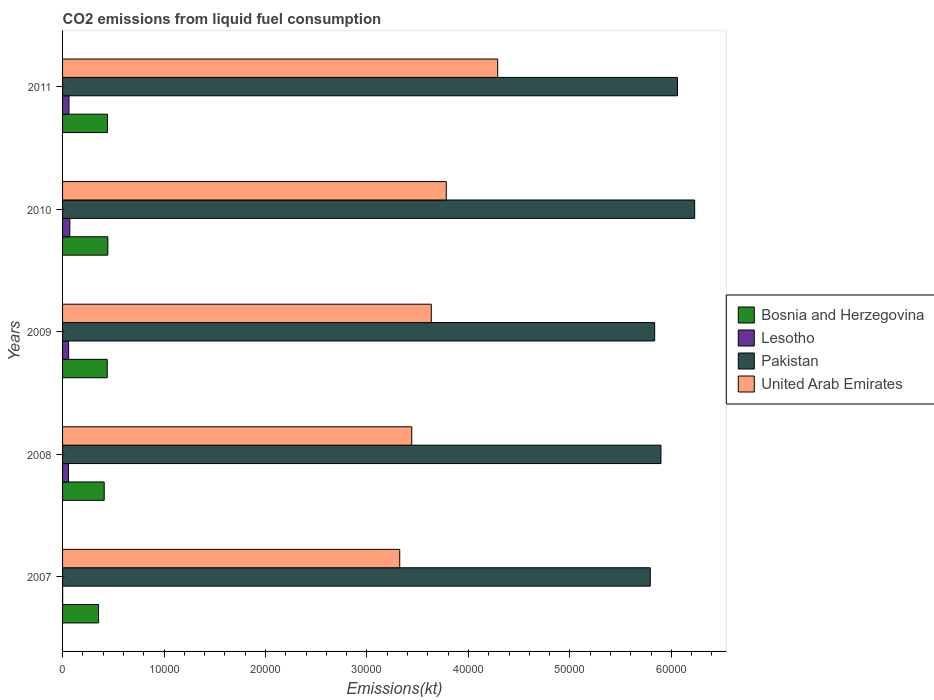How many different coloured bars are there?
Offer a very short reply. 4. How many groups of bars are there?
Ensure brevity in your answer.  5. Are the number of bars per tick equal to the number of legend labels?
Give a very brief answer. Yes. Are the number of bars on each tick of the Y-axis equal?
Keep it short and to the point. Yes. In how many cases, is the number of bars for a given year not equal to the number of legend labels?
Your response must be concise. 0. What is the amount of CO2 emitted in Bosnia and Herzegovina in 2008?
Ensure brevity in your answer.  4103.37. Across all years, what is the maximum amount of CO2 emitted in Lesotho?
Your response must be concise. 715.07. Across all years, what is the minimum amount of CO2 emitted in Bosnia and Herzegovina?
Give a very brief answer. 3545.99. What is the total amount of CO2 emitted in Lesotho in the graph?
Offer a very short reply. 2533.9. What is the difference between the amount of CO2 emitted in Lesotho in 2007 and that in 2009?
Your response must be concise. -586.72. What is the difference between the amount of CO2 emitted in Bosnia and Herzegovina in 2010 and the amount of CO2 emitted in Pakistan in 2011?
Ensure brevity in your answer.  -5.61e+04. What is the average amount of CO2 emitted in Pakistan per year?
Keep it short and to the point. 5.96e+04. In the year 2009, what is the difference between the amount of CO2 emitted in Pakistan and amount of CO2 emitted in Bosnia and Herzegovina?
Offer a very short reply. 5.40e+04. In how many years, is the amount of CO2 emitted in Lesotho greater than 2000 kt?
Ensure brevity in your answer.  0. What is the ratio of the amount of CO2 emitted in Bosnia and Herzegovina in 2007 to that in 2009?
Your answer should be very brief. 0.81. Is the difference between the amount of CO2 emitted in Pakistan in 2007 and 2010 greater than the difference between the amount of CO2 emitted in Bosnia and Herzegovina in 2007 and 2010?
Provide a short and direct response. No. What is the difference between the highest and the second highest amount of CO2 emitted in United Arab Emirates?
Keep it short and to the point. 5067.79. What is the difference between the highest and the lowest amount of CO2 emitted in United Arab Emirates?
Provide a short and direct response. 9655.21. In how many years, is the amount of CO2 emitted in United Arab Emirates greater than the average amount of CO2 emitted in United Arab Emirates taken over all years?
Keep it short and to the point. 2. Is the sum of the amount of CO2 emitted in Pakistan in 2009 and 2011 greater than the maximum amount of CO2 emitted in Lesotho across all years?
Your response must be concise. Yes. Is it the case that in every year, the sum of the amount of CO2 emitted in Lesotho and amount of CO2 emitted in Bosnia and Herzegovina is greater than the sum of amount of CO2 emitted in United Arab Emirates and amount of CO2 emitted in Pakistan?
Provide a succinct answer. No. What does the 1st bar from the top in 2010 represents?
Your answer should be compact. United Arab Emirates. Is it the case that in every year, the sum of the amount of CO2 emitted in Lesotho and amount of CO2 emitted in Pakistan is greater than the amount of CO2 emitted in Bosnia and Herzegovina?
Keep it short and to the point. Yes. How many years are there in the graph?
Your answer should be very brief. 5. Does the graph contain grids?
Your answer should be very brief. No. How many legend labels are there?
Offer a terse response. 4. What is the title of the graph?
Make the answer very short. CO2 emissions from liquid fuel consumption. What is the label or title of the X-axis?
Provide a short and direct response. Emissions(kt). What is the Emissions(kt) of Bosnia and Herzegovina in 2007?
Make the answer very short. 3545.99. What is the Emissions(kt) of Lesotho in 2007?
Ensure brevity in your answer.  7.33. What is the Emissions(kt) in Pakistan in 2007?
Provide a succinct answer. 5.79e+04. What is the Emissions(kt) of United Arab Emirates in 2007?
Provide a short and direct response. 3.32e+04. What is the Emissions(kt) in Bosnia and Herzegovina in 2008?
Give a very brief answer. 4103.37. What is the Emissions(kt) of Lesotho in 2008?
Make the answer very short. 586.72. What is the Emissions(kt) of Pakistan in 2008?
Give a very brief answer. 5.90e+04. What is the Emissions(kt) in United Arab Emirates in 2008?
Your response must be concise. 3.44e+04. What is the Emissions(kt) in Bosnia and Herzegovina in 2009?
Provide a short and direct response. 4400.4. What is the Emissions(kt) in Lesotho in 2009?
Make the answer very short. 594.05. What is the Emissions(kt) of Pakistan in 2009?
Make the answer very short. 5.84e+04. What is the Emissions(kt) of United Arab Emirates in 2009?
Give a very brief answer. 3.63e+04. What is the Emissions(kt) of Bosnia and Herzegovina in 2010?
Your answer should be very brief. 4462.74. What is the Emissions(kt) of Lesotho in 2010?
Offer a terse response. 715.07. What is the Emissions(kt) of Pakistan in 2010?
Give a very brief answer. 6.23e+04. What is the Emissions(kt) in United Arab Emirates in 2010?
Provide a short and direct response. 3.78e+04. What is the Emissions(kt) of Bosnia and Herzegovina in 2011?
Provide a short and direct response. 4422.4. What is the Emissions(kt) in Lesotho in 2011?
Your answer should be compact. 630.72. What is the Emissions(kt) of Pakistan in 2011?
Offer a terse response. 6.06e+04. What is the Emissions(kt) in United Arab Emirates in 2011?
Make the answer very short. 4.29e+04. Across all years, what is the maximum Emissions(kt) of Bosnia and Herzegovina?
Offer a terse response. 4462.74. Across all years, what is the maximum Emissions(kt) in Lesotho?
Your response must be concise. 715.07. Across all years, what is the maximum Emissions(kt) in Pakistan?
Keep it short and to the point. 6.23e+04. Across all years, what is the maximum Emissions(kt) in United Arab Emirates?
Provide a short and direct response. 4.29e+04. Across all years, what is the minimum Emissions(kt) in Bosnia and Herzegovina?
Make the answer very short. 3545.99. Across all years, what is the minimum Emissions(kt) of Lesotho?
Keep it short and to the point. 7.33. Across all years, what is the minimum Emissions(kt) of Pakistan?
Offer a terse response. 5.79e+04. Across all years, what is the minimum Emissions(kt) in United Arab Emirates?
Your response must be concise. 3.32e+04. What is the total Emissions(kt) of Bosnia and Herzegovina in the graph?
Your response must be concise. 2.09e+04. What is the total Emissions(kt) in Lesotho in the graph?
Offer a terse response. 2533.9. What is the total Emissions(kt) in Pakistan in the graph?
Ensure brevity in your answer.  2.98e+05. What is the total Emissions(kt) in United Arab Emirates in the graph?
Offer a very short reply. 1.85e+05. What is the difference between the Emissions(kt) in Bosnia and Herzegovina in 2007 and that in 2008?
Your answer should be very brief. -557.38. What is the difference between the Emissions(kt) in Lesotho in 2007 and that in 2008?
Provide a short and direct response. -579.39. What is the difference between the Emissions(kt) of Pakistan in 2007 and that in 2008?
Ensure brevity in your answer.  -1052.43. What is the difference between the Emissions(kt) in United Arab Emirates in 2007 and that in 2008?
Provide a succinct answer. -1184.44. What is the difference between the Emissions(kt) in Bosnia and Herzegovina in 2007 and that in 2009?
Ensure brevity in your answer.  -854.41. What is the difference between the Emissions(kt) in Lesotho in 2007 and that in 2009?
Keep it short and to the point. -586.72. What is the difference between the Emissions(kt) in Pakistan in 2007 and that in 2009?
Keep it short and to the point. -432.71. What is the difference between the Emissions(kt) of United Arab Emirates in 2007 and that in 2009?
Offer a very short reply. -3109.62. What is the difference between the Emissions(kt) in Bosnia and Herzegovina in 2007 and that in 2010?
Ensure brevity in your answer.  -916.75. What is the difference between the Emissions(kt) of Lesotho in 2007 and that in 2010?
Your answer should be very brief. -707.73. What is the difference between the Emissions(kt) in Pakistan in 2007 and that in 2010?
Your response must be concise. -4374.73. What is the difference between the Emissions(kt) of United Arab Emirates in 2007 and that in 2010?
Ensure brevity in your answer.  -4587.42. What is the difference between the Emissions(kt) in Bosnia and Herzegovina in 2007 and that in 2011?
Offer a terse response. -876.41. What is the difference between the Emissions(kt) of Lesotho in 2007 and that in 2011?
Your answer should be very brief. -623.39. What is the difference between the Emissions(kt) of Pakistan in 2007 and that in 2011?
Make the answer very short. -2684.24. What is the difference between the Emissions(kt) of United Arab Emirates in 2007 and that in 2011?
Your response must be concise. -9655.21. What is the difference between the Emissions(kt) in Bosnia and Herzegovina in 2008 and that in 2009?
Make the answer very short. -297.03. What is the difference between the Emissions(kt) in Lesotho in 2008 and that in 2009?
Your response must be concise. -7.33. What is the difference between the Emissions(kt) of Pakistan in 2008 and that in 2009?
Your response must be concise. 619.72. What is the difference between the Emissions(kt) in United Arab Emirates in 2008 and that in 2009?
Your answer should be very brief. -1925.17. What is the difference between the Emissions(kt) of Bosnia and Herzegovina in 2008 and that in 2010?
Your answer should be very brief. -359.37. What is the difference between the Emissions(kt) of Lesotho in 2008 and that in 2010?
Ensure brevity in your answer.  -128.34. What is the difference between the Emissions(kt) in Pakistan in 2008 and that in 2010?
Provide a short and direct response. -3322.3. What is the difference between the Emissions(kt) in United Arab Emirates in 2008 and that in 2010?
Give a very brief answer. -3402.98. What is the difference between the Emissions(kt) in Bosnia and Herzegovina in 2008 and that in 2011?
Offer a terse response. -319.03. What is the difference between the Emissions(kt) of Lesotho in 2008 and that in 2011?
Keep it short and to the point. -44. What is the difference between the Emissions(kt) of Pakistan in 2008 and that in 2011?
Provide a short and direct response. -1631.82. What is the difference between the Emissions(kt) in United Arab Emirates in 2008 and that in 2011?
Your response must be concise. -8470.77. What is the difference between the Emissions(kt) in Bosnia and Herzegovina in 2009 and that in 2010?
Offer a terse response. -62.34. What is the difference between the Emissions(kt) of Lesotho in 2009 and that in 2010?
Ensure brevity in your answer.  -121.01. What is the difference between the Emissions(kt) of Pakistan in 2009 and that in 2010?
Your response must be concise. -3942.03. What is the difference between the Emissions(kt) in United Arab Emirates in 2009 and that in 2010?
Provide a succinct answer. -1477.8. What is the difference between the Emissions(kt) in Bosnia and Herzegovina in 2009 and that in 2011?
Your response must be concise. -22. What is the difference between the Emissions(kt) in Lesotho in 2009 and that in 2011?
Provide a short and direct response. -36.67. What is the difference between the Emissions(kt) of Pakistan in 2009 and that in 2011?
Keep it short and to the point. -2251.54. What is the difference between the Emissions(kt) in United Arab Emirates in 2009 and that in 2011?
Provide a succinct answer. -6545.6. What is the difference between the Emissions(kt) of Bosnia and Herzegovina in 2010 and that in 2011?
Your response must be concise. 40.34. What is the difference between the Emissions(kt) in Lesotho in 2010 and that in 2011?
Ensure brevity in your answer.  84.34. What is the difference between the Emissions(kt) of Pakistan in 2010 and that in 2011?
Keep it short and to the point. 1690.49. What is the difference between the Emissions(kt) in United Arab Emirates in 2010 and that in 2011?
Offer a very short reply. -5067.79. What is the difference between the Emissions(kt) of Bosnia and Herzegovina in 2007 and the Emissions(kt) of Lesotho in 2008?
Keep it short and to the point. 2959.27. What is the difference between the Emissions(kt) in Bosnia and Herzegovina in 2007 and the Emissions(kt) in Pakistan in 2008?
Offer a very short reply. -5.54e+04. What is the difference between the Emissions(kt) in Bosnia and Herzegovina in 2007 and the Emissions(kt) in United Arab Emirates in 2008?
Ensure brevity in your answer.  -3.09e+04. What is the difference between the Emissions(kt) of Lesotho in 2007 and the Emissions(kt) of Pakistan in 2008?
Provide a short and direct response. -5.90e+04. What is the difference between the Emissions(kt) of Lesotho in 2007 and the Emissions(kt) of United Arab Emirates in 2008?
Offer a terse response. -3.44e+04. What is the difference between the Emissions(kt) in Pakistan in 2007 and the Emissions(kt) in United Arab Emirates in 2008?
Offer a very short reply. 2.35e+04. What is the difference between the Emissions(kt) of Bosnia and Herzegovina in 2007 and the Emissions(kt) of Lesotho in 2009?
Keep it short and to the point. 2951.93. What is the difference between the Emissions(kt) of Bosnia and Herzegovina in 2007 and the Emissions(kt) of Pakistan in 2009?
Offer a very short reply. -5.48e+04. What is the difference between the Emissions(kt) in Bosnia and Herzegovina in 2007 and the Emissions(kt) in United Arab Emirates in 2009?
Give a very brief answer. -3.28e+04. What is the difference between the Emissions(kt) of Lesotho in 2007 and the Emissions(kt) of Pakistan in 2009?
Make the answer very short. -5.83e+04. What is the difference between the Emissions(kt) in Lesotho in 2007 and the Emissions(kt) in United Arab Emirates in 2009?
Give a very brief answer. -3.63e+04. What is the difference between the Emissions(kt) of Pakistan in 2007 and the Emissions(kt) of United Arab Emirates in 2009?
Your response must be concise. 2.16e+04. What is the difference between the Emissions(kt) of Bosnia and Herzegovina in 2007 and the Emissions(kt) of Lesotho in 2010?
Give a very brief answer. 2830.92. What is the difference between the Emissions(kt) of Bosnia and Herzegovina in 2007 and the Emissions(kt) of Pakistan in 2010?
Your answer should be very brief. -5.88e+04. What is the difference between the Emissions(kt) of Bosnia and Herzegovina in 2007 and the Emissions(kt) of United Arab Emirates in 2010?
Provide a short and direct response. -3.43e+04. What is the difference between the Emissions(kt) of Lesotho in 2007 and the Emissions(kt) of Pakistan in 2010?
Give a very brief answer. -6.23e+04. What is the difference between the Emissions(kt) of Lesotho in 2007 and the Emissions(kt) of United Arab Emirates in 2010?
Your answer should be very brief. -3.78e+04. What is the difference between the Emissions(kt) in Pakistan in 2007 and the Emissions(kt) in United Arab Emirates in 2010?
Your answer should be very brief. 2.01e+04. What is the difference between the Emissions(kt) of Bosnia and Herzegovina in 2007 and the Emissions(kt) of Lesotho in 2011?
Keep it short and to the point. 2915.26. What is the difference between the Emissions(kt) of Bosnia and Herzegovina in 2007 and the Emissions(kt) of Pakistan in 2011?
Keep it short and to the point. -5.71e+04. What is the difference between the Emissions(kt) in Bosnia and Herzegovina in 2007 and the Emissions(kt) in United Arab Emirates in 2011?
Keep it short and to the point. -3.93e+04. What is the difference between the Emissions(kt) of Lesotho in 2007 and the Emissions(kt) of Pakistan in 2011?
Your response must be concise. -6.06e+04. What is the difference between the Emissions(kt) of Lesotho in 2007 and the Emissions(kt) of United Arab Emirates in 2011?
Keep it short and to the point. -4.29e+04. What is the difference between the Emissions(kt) in Pakistan in 2007 and the Emissions(kt) in United Arab Emirates in 2011?
Your answer should be very brief. 1.50e+04. What is the difference between the Emissions(kt) in Bosnia and Herzegovina in 2008 and the Emissions(kt) in Lesotho in 2009?
Give a very brief answer. 3509.32. What is the difference between the Emissions(kt) in Bosnia and Herzegovina in 2008 and the Emissions(kt) in Pakistan in 2009?
Your response must be concise. -5.43e+04. What is the difference between the Emissions(kt) in Bosnia and Herzegovina in 2008 and the Emissions(kt) in United Arab Emirates in 2009?
Your answer should be compact. -3.22e+04. What is the difference between the Emissions(kt) of Lesotho in 2008 and the Emissions(kt) of Pakistan in 2009?
Give a very brief answer. -5.78e+04. What is the difference between the Emissions(kt) in Lesotho in 2008 and the Emissions(kt) in United Arab Emirates in 2009?
Your answer should be very brief. -3.58e+04. What is the difference between the Emissions(kt) of Pakistan in 2008 and the Emissions(kt) of United Arab Emirates in 2009?
Your answer should be very brief. 2.26e+04. What is the difference between the Emissions(kt) of Bosnia and Herzegovina in 2008 and the Emissions(kt) of Lesotho in 2010?
Keep it short and to the point. 3388.31. What is the difference between the Emissions(kt) of Bosnia and Herzegovina in 2008 and the Emissions(kt) of Pakistan in 2010?
Provide a succinct answer. -5.82e+04. What is the difference between the Emissions(kt) in Bosnia and Herzegovina in 2008 and the Emissions(kt) in United Arab Emirates in 2010?
Make the answer very short. -3.37e+04. What is the difference between the Emissions(kt) in Lesotho in 2008 and the Emissions(kt) in Pakistan in 2010?
Ensure brevity in your answer.  -6.17e+04. What is the difference between the Emissions(kt) of Lesotho in 2008 and the Emissions(kt) of United Arab Emirates in 2010?
Provide a succinct answer. -3.72e+04. What is the difference between the Emissions(kt) of Pakistan in 2008 and the Emissions(kt) of United Arab Emirates in 2010?
Your response must be concise. 2.12e+04. What is the difference between the Emissions(kt) of Bosnia and Herzegovina in 2008 and the Emissions(kt) of Lesotho in 2011?
Ensure brevity in your answer.  3472.65. What is the difference between the Emissions(kt) of Bosnia and Herzegovina in 2008 and the Emissions(kt) of Pakistan in 2011?
Your answer should be compact. -5.65e+04. What is the difference between the Emissions(kt) of Bosnia and Herzegovina in 2008 and the Emissions(kt) of United Arab Emirates in 2011?
Offer a terse response. -3.88e+04. What is the difference between the Emissions(kt) in Lesotho in 2008 and the Emissions(kt) in Pakistan in 2011?
Ensure brevity in your answer.  -6.00e+04. What is the difference between the Emissions(kt) of Lesotho in 2008 and the Emissions(kt) of United Arab Emirates in 2011?
Give a very brief answer. -4.23e+04. What is the difference between the Emissions(kt) in Pakistan in 2008 and the Emissions(kt) in United Arab Emirates in 2011?
Make the answer very short. 1.61e+04. What is the difference between the Emissions(kt) in Bosnia and Herzegovina in 2009 and the Emissions(kt) in Lesotho in 2010?
Provide a succinct answer. 3685.34. What is the difference between the Emissions(kt) of Bosnia and Herzegovina in 2009 and the Emissions(kt) of Pakistan in 2010?
Make the answer very short. -5.79e+04. What is the difference between the Emissions(kt) of Bosnia and Herzegovina in 2009 and the Emissions(kt) of United Arab Emirates in 2010?
Keep it short and to the point. -3.34e+04. What is the difference between the Emissions(kt) in Lesotho in 2009 and the Emissions(kt) in Pakistan in 2010?
Keep it short and to the point. -6.17e+04. What is the difference between the Emissions(kt) of Lesotho in 2009 and the Emissions(kt) of United Arab Emirates in 2010?
Make the answer very short. -3.72e+04. What is the difference between the Emissions(kt) of Pakistan in 2009 and the Emissions(kt) of United Arab Emirates in 2010?
Provide a succinct answer. 2.05e+04. What is the difference between the Emissions(kt) in Bosnia and Herzegovina in 2009 and the Emissions(kt) in Lesotho in 2011?
Your answer should be compact. 3769.68. What is the difference between the Emissions(kt) of Bosnia and Herzegovina in 2009 and the Emissions(kt) of Pakistan in 2011?
Your answer should be compact. -5.62e+04. What is the difference between the Emissions(kt) in Bosnia and Herzegovina in 2009 and the Emissions(kt) in United Arab Emirates in 2011?
Your answer should be very brief. -3.85e+04. What is the difference between the Emissions(kt) of Lesotho in 2009 and the Emissions(kt) of Pakistan in 2011?
Provide a succinct answer. -6.00e+04. What is the difference between the Emissions(kt) in Lesotho in 2009 and the Emissions(kt) in United Arab Emirates in 2011?
Your answer should be compact. -4.23e+04. What is the difference between the Emissions(kt) of Pakistan in 2009 and the Emissions(kt) of United Arab Emirates in 2011?
Provide a succinct answer. 1.55e+04. What is the difference between the Emissions(kt) of Bosnia and Herzegovina in 2010 and the Emissions(kt) of Lesotho in 2011?
Offer a terse response. 3832.01. What is the difference between the Emissions(kt) in Bosnia and Herzegovina in 2010 and the Emissions(kt) in Pakistan in 2011?
Provide a short and direct response. -5.61e+04. What is the difference between the Emissions(kt) in Bosnia and Herzegovina in 2010 and the Emissions(kt) in United Arab Emirates in 2011?
Your answer should be compact. -3.84e+04. What is the difference between the Emissions(kt) of Lesotho in 2010 and the Emissions(kt) of Pakistan in 2011?
Your answer should be compact. -5.99e+04. What is the difference between the Emissions(kt) in Lesotho in 2010 and the Emissions(kt) in United Arab Emirates in 2011?
Offer a terse response. -4.22e+04. What is the difference between the Emissions(kt) in Pakistan in 2010 and the Emissions(kt) in United Arab Emirates in 2011?
Provide a short and direct response. 1.94e+04. What is the average Emissions(kt) of Bosnia and Herzegovina per year?
Your answer should be compact. 4186.98. What is the average Emissions(kt) in Lesotho per year?
Make the answer very short. 506.78. What is the average Emissions(kt) in Pakistan per year?
Provide a succinct answer. 5.96e+04. What is the average Emissions(kt) of United Arab Emirates per year?
Ensure brevity in your answer.  3.69e+04. In the year 2007, what is the difference between the Emissions(kt) in Bosnia and Herzegovina and Emissions(kt) in Lesotho?
Keep it short and to the point. 3538.66. In the year 2007, what is the difference between the Emissions(kt) of Bosnia and Herzegovina and Emissions(kt) of Pakistan?
Make the answer very short. -5.44e+04. In the year 2007, what is the difference between the Emissions(kt) of Bosnia and Herzegovina and Emissions(kt) of United Arab Emirates?
Make the answer very short. -2.97e+04. In the year 2007, what is the difference between the Emissions(kt) in Lesotho and Emissions(kt) in Pakistan?
Provide a succinct answer. -5.79e+04. In the year 2007, what is the difference between the Emissions(kt) of Lesotho and Emissions(kt) of United Arab Emirates?
Your answer should be very brief. -3.32e+04. In the year 2007, what is the difference between the Emissions(kt) of Pakistan and Emissions(kt) of United Arab Emirates?
Your response must be concise. 2.47e+04. In the year 2008, what is the difference between the Emissions(kt) of Bosnia and Herzegovina and Emissions(kt) of Lesotho?
Make the answer very short. 3516.65. In the year 2008, what is the difference between the Emissions(kt) of Bosnia and Herzegovina and Emissions(kt) of Pakistan?
Offer a terse response. -5.49e+04. In the year 2008, what is the difference between the Emissions(kt) in Bosnia and Herzegovina and Emissions(kt) in United Arab Emirates?
Your answer should be very brief. -3.03e+04. In the year 2008, what is the difference between the Emissions(kt) of Lesotho and Emissions(kt) of Pakistan?
Offer a very short reply. -5.84e+04. In the year 2008, what is the difference between the Emissions(kt) of Lesotho and Emissions(kt) of United Arab Emirates?
Give a very brief answer. -3.38e+04. In the year 2008, what is the difference between the Emissions(kt) of Pakistan and Emissions(kt) of United Arab Emirates?
Ensure brevity in your answer.  2.46e+04. In the year 2009, what is the difference between the Emissions(kt) in Bosnia and Herzegovina and Emissions(kt) in Lesotho?
Give a very brief answer. 3806.35. In the year 2009, what is the difference between the Emissions(kt) of Bosnia and Herzegovina and Emissions(kt) of Pakistan?
Ensure brevity in your answer.  -5.40e+04. In the year 2009, what is the difference between the Emissions(kt) of Bosnia and Herzegovina and Emissions(kt) of United Arab Emirates?
Offer a very short reply. -3.19e+04. In the year 2009, what is the difference between the Emissions(kt) of Lesotho and Emissions(kt) of Pakistan?
Your response must be concise. -5.78e+04. In the year 2009, what is the difference between the Emissions(kt) of Lesotho and Emissions(kt) of United Arab Emirates?
Make the answer very short. -3.57e+04. In the year 2009, what is the difference between the Emissions(kt) of Pakistan and Emissions(kt) of United Arab Emirates?
Your answer should be very brief. 2.20e+04. In the year 2010, what is the difference between the Emissions(kt) of Bosnia and Herzegovina and Emissions(kt) of Lesotho?
Make the answer very short. 3747.67. In the year 2010, what is the difference between the Emissions(kt) of Bosnia and Herzegovina and Emissions(kt) of Pakistan?
Provide a succinct answer. -5.78e+04. In the year 2010, what is the difference between the Emissions(kt) in Bosnia and Herzegovina and Emissions(kt) in United Arab Emirates?
Give a very brief answer. -3.34e+04. In the year 2010, what is the difference between the Emissions(kt) in Lesotho and Emissions(kt) in Pakistan?
Provide a short and direct response. -6.16e+04. In the year 2010, what is the difference between the Emissions(kt) of Lesotho and Emissions(kt) of United Arab Emirates?
Provide a succinct answer. -3.71e+04. In the year 2010, what is the difference between the Emissions(kt) in Pakistan and Emissions(kt) in United Arab Emirates?
Provide a succinct answer. 2.45e+04. In the year 2011, what is the difference between the Emissions(kt) of Bosnia and Herzegovina and Emissions(kt) of Lesotho?
Ensure brevity in your answer.  3791.68. In the year 2011, what is the difference between the Emissions(kt) in Bosnia and Herzegovina and Emissions(kt) in Pakistan?
Your answer should be compact. -5.62e+04. In the year 2011, what is the difference between the Emissions(kt) in Bosnia and Herzegovina and Emissions(kt) in United Arab Emirates?
Provide a succinct answer. -3.85e+04. In the year 2011, what is the difference between the Emissions(kt) of Lesotho and Emissions(kt) of Pakistan?
Ensure brevity in your answer.  -6.00e+04. In the year 2011, what is the difference between the Emissions(kt) of Lesotho and Emissions(kt) of United Arab Emirates?
Offer a very short reply. -4.23e+04. In the year 2011, what is the difference between the Emissions(kt) in Pakistan and Emissions(kt) in United Arab Emirates?
Your response must be concise. 1.77e+04. What is the ratio of the Emissions(kt) in Bosnia and Herzegovina in 2007 to that in 2008?
Your answer should be compact. 0.86. What is the ratio of the Emissions(kt) in Lesotho in 2007 to that in 2008?
Your answer should be compact. 0.01. What is the ratio of the Emissions(kt) in Pakistan in 2007 to that in 2008?
Your response must be concise. 0.98. What is the ratio of the Emissions(kt) of United Arab Emirates in 2007 to that in 2008?
Offer a very short reply. 0.97. What is the ratio of the Emissions(kt) of Bosnia and Herzegovina in 2007 to that in 2009?
Give a very brief answer. 0.81. What is the ratio of the Emissions(kt) in Lesotho in 2007 to that in 2009?
Ensure brevity in your answer.  0.01. What is the ratio of the Emissions(kt) of United Arab Emirates in 2007 to that in 2009?
Offer a terse response. 0.91. What is the ratio of the Emissions(kt) in Bosnia and Herzegovina in 2007 to that in 2010?
Give a very brief answer. 0.79. What is the ratio of the Emissions(kt) in Lesotho in 2007 to that in 2010?
Give a very brief answer. 0.01. What is the ratio of the Emissions(kt) of Pakistan in 2007 to that in 2010?
Offer a terse response. 0.93. What is the ratio of the Emissions(kt) of United Arab Emirates in 2007 to that in 2010?
Your response must be concise. 0.88. What is the ratio of the Emissions(kt) in Bosnia and Herzegovina in 2007 to that in 2011?
Your answer should be compact. 0.8. What is the ratio of the Emissions(kt) of Lesotho in 2007 to that in 2011?
Give a very brief answer. 0.01. What is the ratio of the Emissions(kt) in Pakistan in 2007 to that in 2011?
Provide a short and direct response. 0.96. What is the ratio of the Emissions(kt) of United Arab Emirates in 2007 to that in 2011?
Your answer should be compact. 0.77. What is the ratio of the Emissions(kt) in Bosnia and Herzegovina in 2008 to that in 2009?
Ensure brevity in your answer.  0.93. What is the ratio of the Emissions(kt) in Lesotho in 2008 to that in 2009?
Give a very brief answer. 0.99. What is the ratio of the Emissions(kt) in Pakistan in 2008 to that in 2009?
Give a very brief answer. 1.01. What is the ratio of the Emissions(kt) in United Arab Emirates in 2008 to that in 2009?
Your response must be concise. 0.95. What is the ratio of the Emissions(kt) in Bosnia and Herzegovina in 2008 to that in 2010?
Ensure brevity in your answer.  0.92. What is the ratio of the Emissions(kt) in Lesotho in 2008 to that in 2010?
Offer a terse response. 0.82. What is the ratio of the Emissions(kt) in Pakistan in 2008 to that in 2010?
Make the answer very short. 0.95. What is the ratio of the Emissions(kt) of United Arab Emirates in 2008 to that in 2010?
Your response must be concise. 0.91. What is the ratio of the Emissions(kt) in Bosnia and Herzegovina in 2008 to that in 2011?
Your answer should be very brief. 0.93. What is the ratio of the Emissions(kt) in Lesotho in 2008 to that in 2011?
Make the answer very short. 0.93. What is the ratio of the Emissions(kt) of Pakistan in 2008 to that in 2011?
Your answer should be very brief. 0.97. What is the ratio of the Emissions(kt) in United Arab Emirates in 2008 to that in 2011?
Your response must be concise. 0.8. What is the ratio of the Emissions(kt) of Lesotho in 2009 to that in 2010?
Your answer should be very brief. 0.83. What is the ratio of the Emissions(kt) in Pakistan in 2009 to that in 2010?
Your answer should be compact. 0.94. What is the ratio of the Emissions(kt) in United Arab Emirates in 2009 to that in 2010?
Your answer should be compact. 0.96. What is the ratio of the Emissions(kt) in Lesotho in 2009 to that in 2011?
Provide a short and direct response. 0.94. What is the ratio of the Emissions(kt) in Pakistan in 2009 to that in 2011?
Ensure brevity in your answer.  0.96. What is the ratio of the Emissions(kt) of United Arab Emirates in 2009 to that in 2011?
Keep it short and to the point. 0.85. What is the ratio of the Emissions(kt) in Bosnia and Herzegovina in 2010 to that in 2011?
Ensure brevity in your answer.  1.01. What is the ratio of the Emissions(kt) in Lesotho in 2010 to that in 2011?
Provide a short and direct response. 1.13. What is the ratio of the Emissions(kt) of Pakistan in 2010 to that in 2011?
Provide a short and direct response. 1.03. What is the ratio of the Emissions(kt) in United Arab Emirates in 2010 to that in 2011?
Offer a terse response. 0.88. What is the difference between the highest and the second highest Emissions(kt) of Bosnia and Herzegovina?
Offer a terse response. 40.34. What is the difference between the highest and the second highest Emissions(kt) of Lesotho?
Your response must be concise. 84.34. What is the difference between the highest and the second highest Emissions(kt) in Pakistan?
Offer a terse response. 1690.49. What is the difference between the highest and the second highest Emissions(kt) in United Arab Emirates?
Provide a short and direct response. 5067.79. What is the difference between the highest and the lowest Emissions(kt) in Bosnia and Herzegovina?
Offer a terse response. 916.75. What is the difference between the highest and the lowest Emissions(kt) in Lesotho?
Your response must be concise. 707.73. What is the difference between the highest and the lowest Emissions(kt) of Pakistan?
Your response must be concise. 4374.73. What is the difference between the highest and the lowest Emissions(kt) in United Arab Emirates?
Keep it short and to the point. 9655.21. 